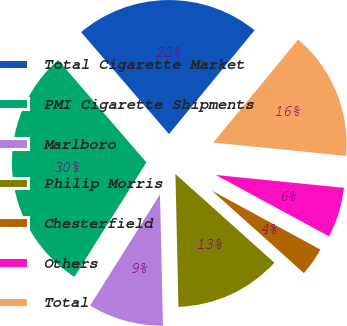Convert chart. <chart><loc_0><loc_0><loc_500><loc_500><pie_chart><fcel>Total Cigarette Market<fcel>PMI Cigarette Shipments<fcel>Marlboro<fcel>Philip Morris<fcel>Chesterfield<fcel>Others<fcel>Total<nl><fcel>22.3%<fcel>29.74%<fcel>9.29%<fcel>13.01%<fcel>3.72%<fcel>6.32%<fcel>15.61%<nl></chart> 